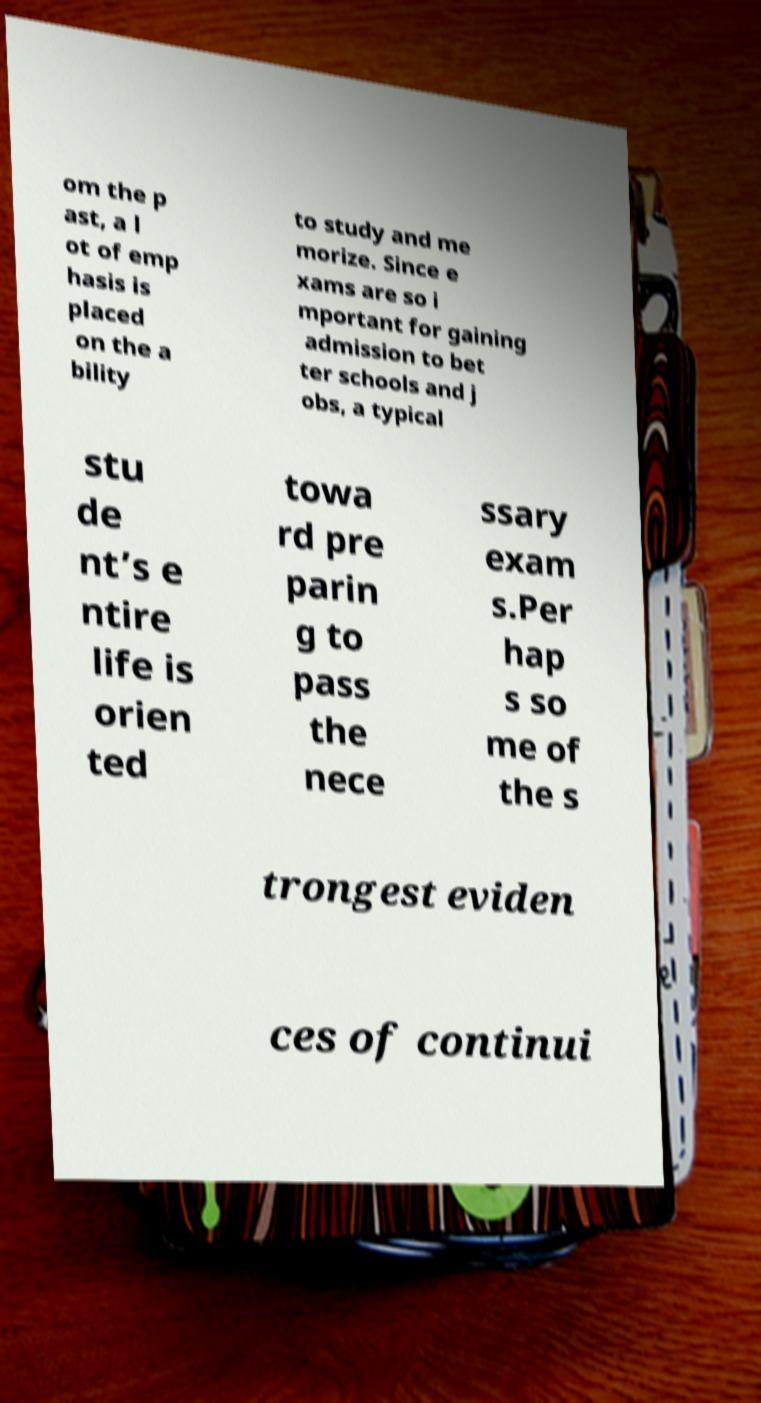Can you accurately transcribe the text from the provided image for me? om the p ast, a l ot of emp hasis is placed on the a bility to study and me morize. Since e xams are so i mportant for gaining admission to bet ter schools and j obs, a typical stu de nt’s e ntire life is orien ted towa rd pre parin g to pass the nece ssary exam s.Per hap s so me of the s trongest eviden ces of continui 